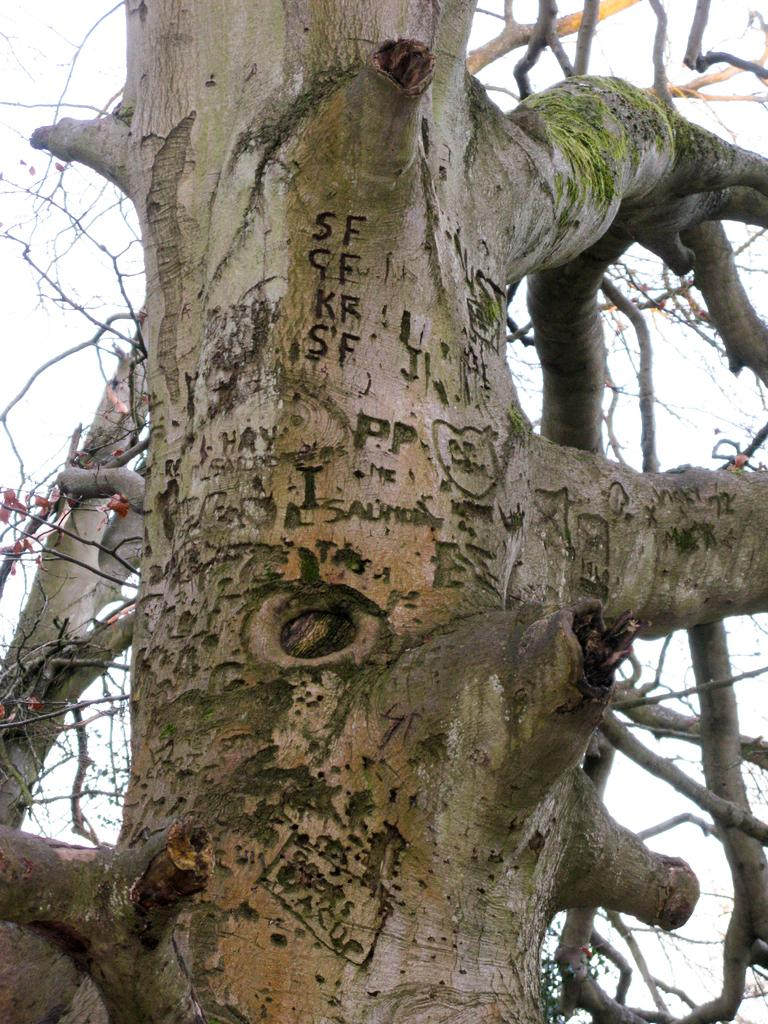What is on the tree branch in the image? There is an object on the tree branch. Can you describe the object on the tree branch? Unfortunately, the object on the tree branch cannot be definitively described with the information provided. What can be seen in the background of the image? The sky is visible in the background of the image. What type of shop can be seen in the image? There is no shop present in the image. What is the position of the sun in the image? The facts provided do not mention the sun, so we cannot determine its position in the image. 